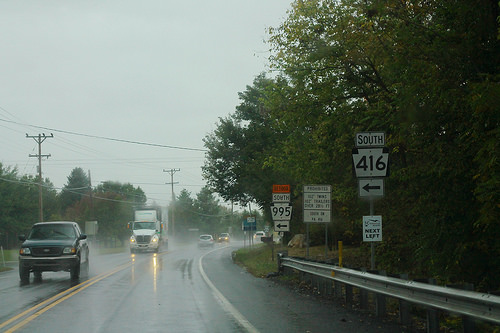<image>
Can you confirm if the car is to the right of the tree? No. The car is not to the right of the tree. The horizontal positioning shows a different relationship. 